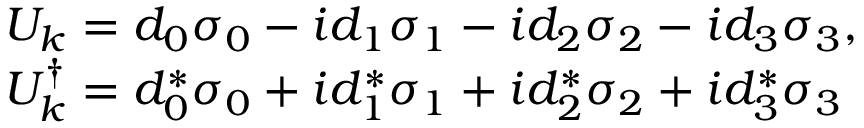<formula> <loc_0><loc_0><loc_500><loc_500>\begin{array} { r l } & { U _ { k } = d _ { 0 } \sigma _ { 0 } - i d _ { 1 } \sigma _ { 1 } - i d _ { 2 } \sigma _ { 2 } - i d _ { 3 } \sigma _ { 3 } , } \\ & { U _ { k } ^ { \dagger } = d _ { 0 } ^ { \ast } \sigma _ { 0 } + i d _ { 1 } ^ { \ast } \sigma _ { 1 } + i d _ { 2 } ^ { \ast } \sigma _ { 2 } + i d _ { 3 } ^ { \ast } \sigma _ { 3 } } \end{array}</formula> 